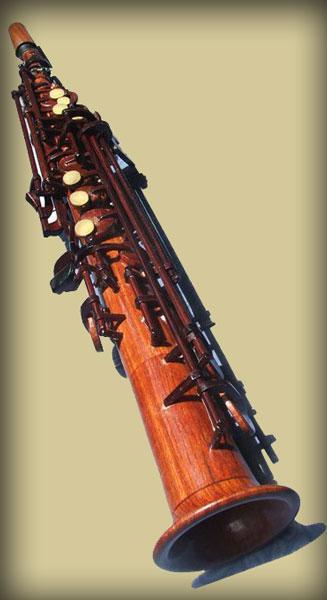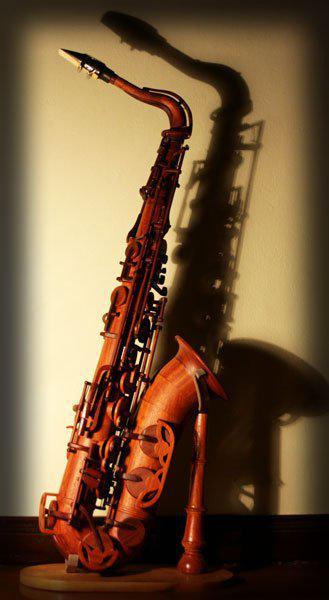The first image is the image on the left, the second image is the image on the right. For the images shown, is this caption "The entire instrument is visible in every image." true? Answer yes or no. Yes. 